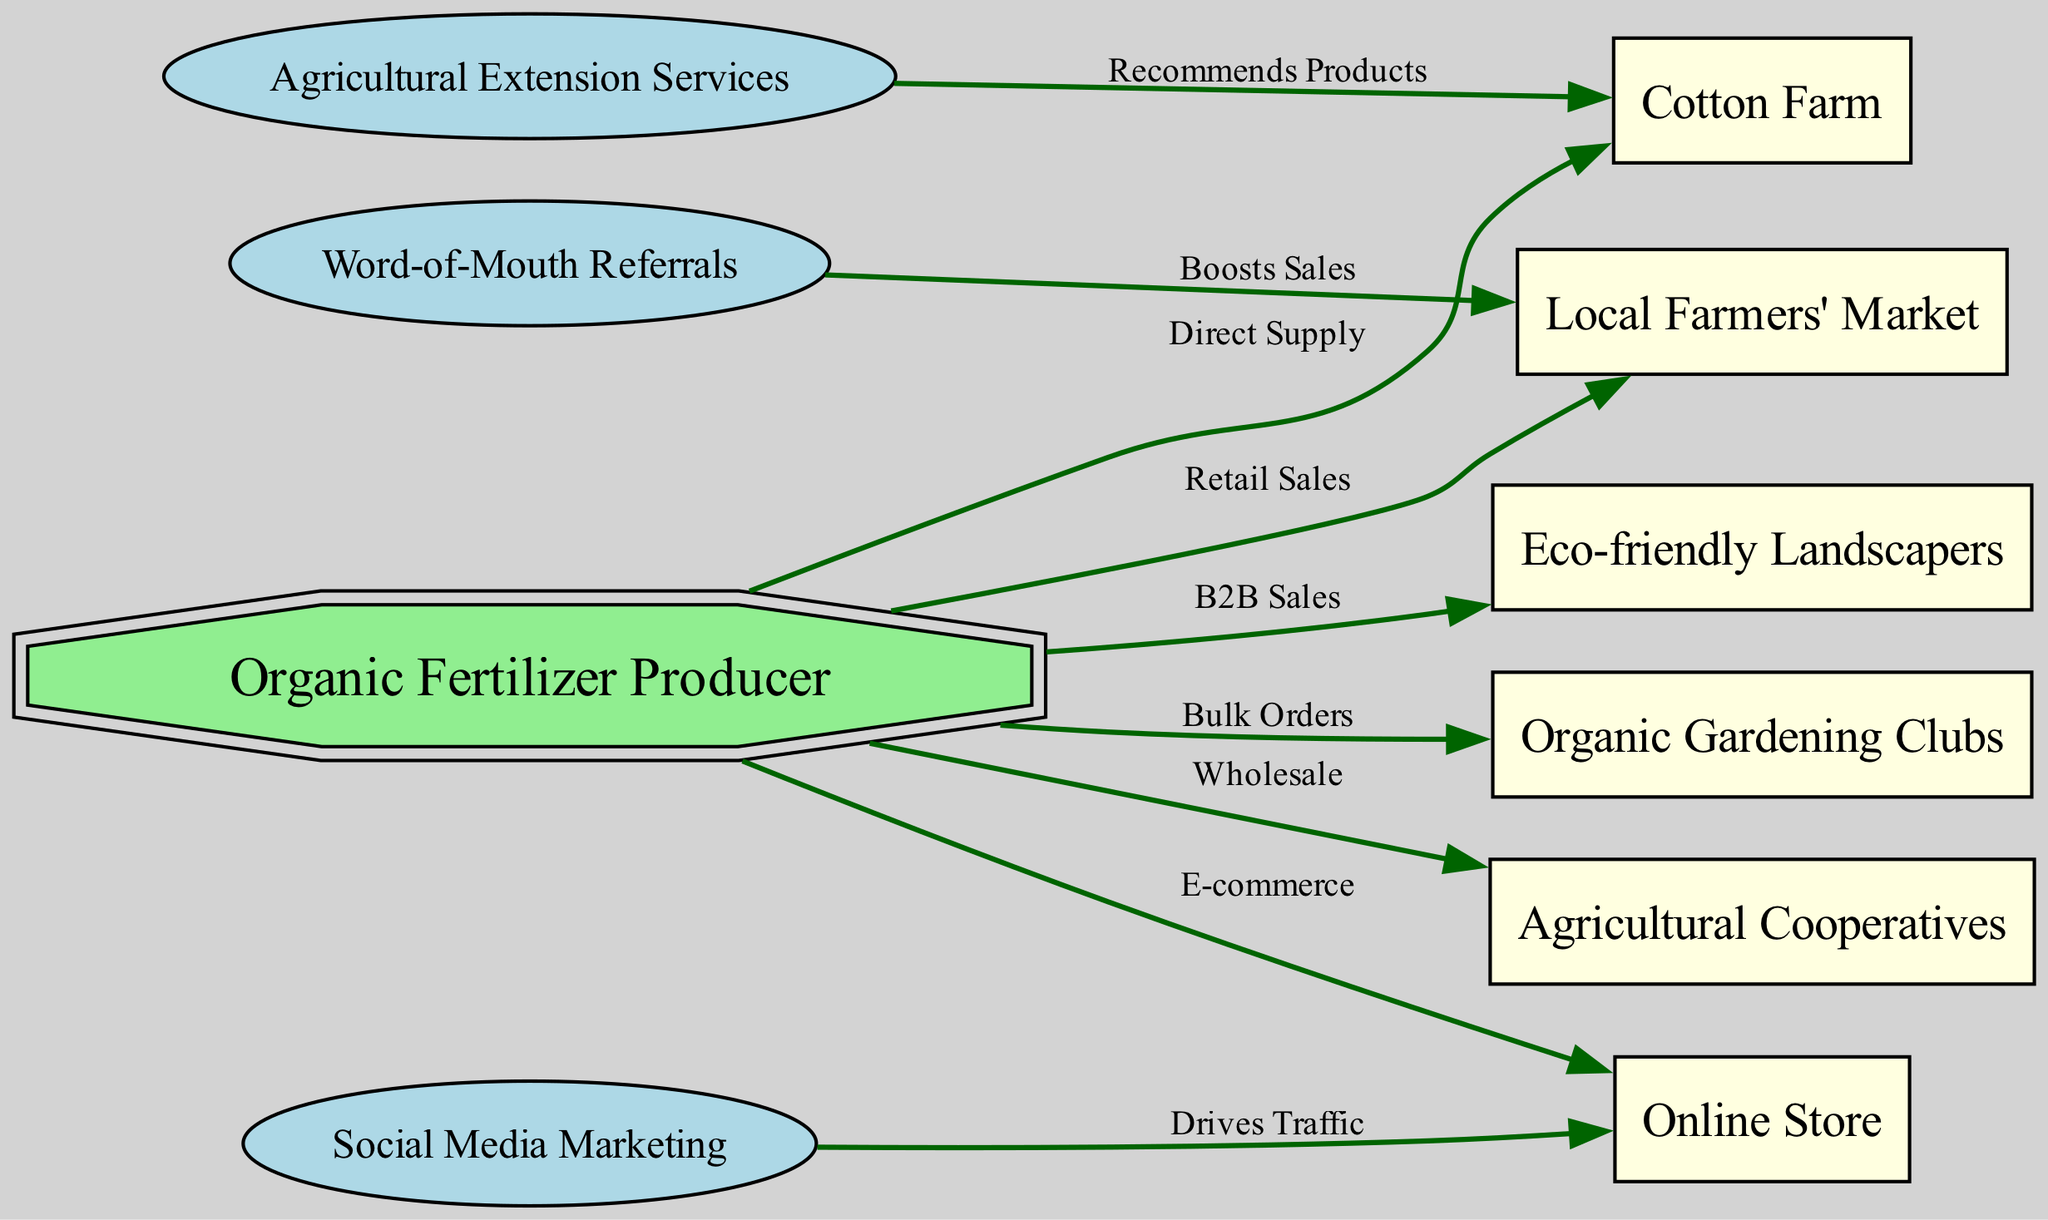What is the total number of nodes in the diagram? The diagram includes several distinct elements representing various entities. To determine the total number of nodes, we count each of them in the list provided: Organic Fertilizer Producer, Cotton Farm, Local Farmers' Market, Online Store, Organic Gardening Clubs, Agricultural Cooperatives, Eco-friendly Landscapers, Social Media Marketing, Word-of-Mouth Referrals, and Agricultural Extension Services. This gives us 10 nodes in total.
Answer: 10 Which node receives “Direct Supply” from the Organic Fertilizer Producer? In the diagram, the relationship labeled “Direct Supply” indicates a direct connection from the Organic Fertilizer Producer to another node. By examining the edges, it is clear that “Cotton Farm” is the only node that receives this direct supply from the Organic Fertilizer Producer.
Answer: Cotton Farm How many different sales methods are illustrated in the diagram? The diagram presents several methods through which the Organic Fertilizer Producer distributes its products to various customer segments. By analyzing the edges emanating from the Organic Fertilizer Producer, we count retail sales, e-commerce, bulk orders, wholesale, and B2B sales as distinct methods. This results in a total of five different sales methods documented in the diagram.
Answer: 5 Which customer segment is boosted by "Word-of-Mouth Referrals"? To identify the customer segment influenced by “Word-of-Mouth Referrals,” we look at the outgoing edge labeled “Boosts Sales.” This edge shows a connection from Word-of-Mouth Referrals to the Local Farmers' Market. Thus, we can conclude that the Local Farmers' Market is the customer segment that benefits from this type of referral.
Answer: Local Farmers' Market What type of marketing drives traffic to the Online Store? The diagram highlights various marketing techniques. By examining the edges, we find a directed connection labeled “Drives Traffic” from Social Media Marketing to the Online Store. This indicates that Social Media Marketing is the specific technique driving traffic towards the Online Store.
Answer: Social Media Marketing What relationship exists between Agricultural Extension Services and Cotton Farm? In the diagram, the edge between Agricultural Extension Services and Cotton Farm is labeled “Recommends Products.” This label describes a relationship where Agricultural Extension Services plays a role in suggesting or endorsing products to the Cotton Farm. Hence, the relationship is one of recommendation.
Answer: Recommends Products Which node illustrates the concept of "Bulk Orders"? The edge depicting the Bulk Orders relationship is directed from the Organic Fertilizer Producer to another node. When reviewing the edges in the diagram, we see that the node associated with Bulk Orders is the Organic Gardening Clubs. Therefore, Organic Gardening Clubs is the designated node for this concept.
Answer: Organic Gardening Clubs How many B2B sales connections are represented in the diagram? To find the number of B2B sales connections, we check each directed edge from the Organic Fertilizer Producer. Only one edge is labeled “B2B Sales,” which connects the Organic Fertilizer Producer to Eco-friendly Landscapers. Therefore, there is a single B2B sales connection in the diagram.
Answer: 1 